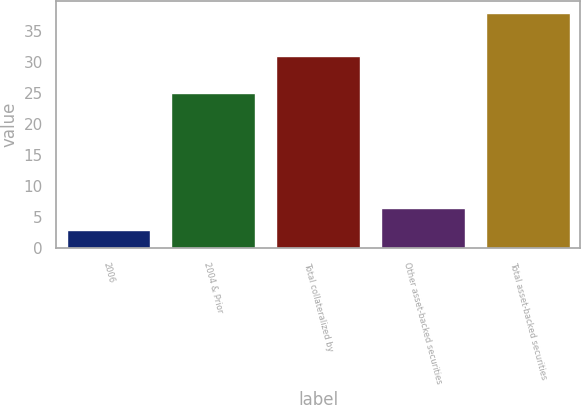Convert chart. <chart><loc_0><loc_0><loc_500><loc_500><bar_chart><fcel>2006<fcel>2004 & Prior<fcel>Total collateralized by<fcel>Other asset-backed securities<fcel>Total asset-backed securities<nl><fcel>3<fcel>25<fcel>31<fcel>6.5<fcel>38<nl></chart> 